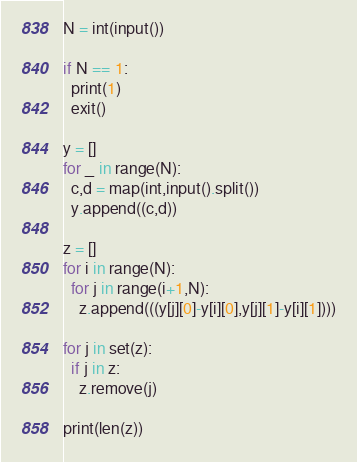<code> <loc_0><loc_0><loc_500><loc_500><_Python_>N = int(input())

if N == 1:
  print(1)
  exit()

y = []
for _ in range(N):
  c,d = map(int,input().split())
  y.append((c,d))

z = []
for i in range(N):
  for j in range(i+1,N):
    z.append(((y[j][0]-y[i][0],y[j][1]-y[i][1])))
    
for j in set(z):
  if j in z:
    z.remove(j)
       
print(len(z))</code> 